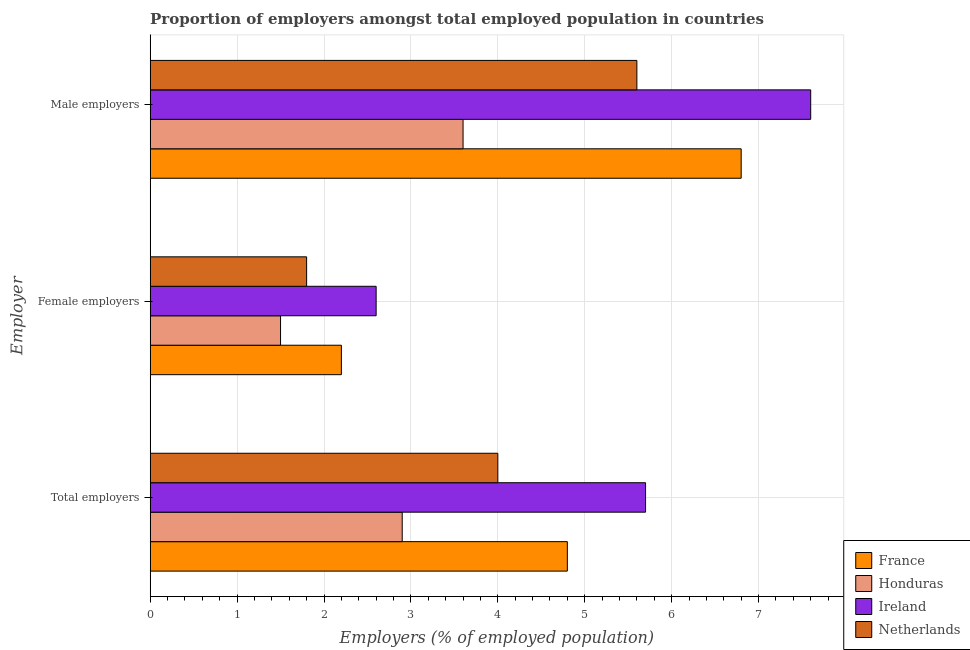How many groups of bars are there?
Offer a very short reply. 3. Are the number of bars per tick equal to the number of legend labels?
Ensure brevity in your answer.  Yes. Are the number of bars on each tick of the Y-axis equal?
Offer a very short reply. Yes. How many bars are there on the 2nd tick from the top?
Your response must be concise. 4. How many bars are there on the 2nd tick from the bottom?
Ensure brevity in your answer.  4. What is the label of the 2nd group of bars from the top?
Give a very brief answer. Female employers. What is the percentage of total employers in Netherlands?
Offer a terse response. 4. Across all countries, what is the maximum percentage of male employers?
Your answer should be very brief. 7.6. Across all countries, what is the minimum percentage of male employers?
Offer a terse response. 3.6. In which country was the percentage of male employers maximum?
Give a very brief answer. Ireland. In which country was the percentage of male employers minimum?
Offer a very short reply. Honduras. What is the total percentage of total employers in the graph?
Your answer should be compact. 17.4. What is the difference between the percentage of female employers in Ireland and that in France?
Your response must be concise. 0.4. What is the difference between the percentage of male employers in France and the percentage of total employers in Honduras?
Make the answer very short. 3.9. What is the average percentage of female employers per country?
Ensure brevity in your answer.  2.02. What is the difference between the percentage of female employers and percentage of male employers in Netherlands?
Offer a very short reply. -3.8. What is the ratio of the percentage of male employers in France to that in Netherlands?
Offer a terse response. 1.21. What is the difference between the highest and the second highest percentage of female employers?
Your response must be concise. 0.4. What is the difference between the highest and the lowest percentage of total employers?
Your answer should be compact. 2.8. Is the sum of the percentage of male employers in Honduras and Netherlands greater than the maximum percentage of female employers across all countries?
Keep it short and to the point. Yes. What does the 3rd bar from the top in Female employers represents?
Provide a succinct answer. Honduras. What does the 1st bar from the bottom in Total employers represents?
Give a very brief answer. France. Is it the case that in every country, the sum of the percentage of total employers and percentage of female employers is greater than the percentage of male employers?
Make the answer very short. Yes. How many bars are there?
Ensure brevity in your answer.  12. How many countries are there in the graph?
Your answer should be compact. 4. Does the graph contain any zero values?
Your answer should be compact. No. Does the graph contain grids?
Provide a short and direct response. Yes. How many legend labels are there?
Keep it short and to the point. 4. What is the title of the graph?
Your answer should be compact. Proportion of employers amongst total employed population in countries. Does "High income" appear as one of the legend labels in the graph?
Ensure brevity in your answer.  No. What is the label or title of the X-axis?
Offer a very short reply. Employers (% of employed population). What is the label or title of the Y-axis?
Make the answer very short. Employer. What is the Employers (% of employed population) of France in Total employers?
Keep it short and to the point. 4.8. What is the Employers (% of employed population) in Honduras in Total employers?
Provide a succinct answer. 2.9. What is the Employers (% of employed population) of Ireland in Total employers?
Make the answer very short. 5.7. What is the Employers (% of employed population) of Netherlands in Total employers?
Your answer should be compact. 4. What is the Employers (% of employed population) of France in Female employers?
Provide a succinct answer. 2.2. What is the Employers (% of employed population) of Ireland in Female employers?
Give a very brief answer. 2.6. What is the Employers (% of employed population) in Netherlands in Female employers?
Your response must be concise. 1.8. What is the Employers (% of employed population) of France in Male employers?
Keep it short and to the point. 6.8. What is the Employers (% of employed population) of Honduras in Male employers?
Keep it short and to the point. 3.6. What is the Employers (% of employed population) in Ireland in Male employers?
Your answer should be very brief. 7.6. What is the Employers (% of employed population) of Netherlands in Male employers?
Provide a succinct answer. 5.6. Across all Employer, what is the maximum Employers (% of employed population) in France?
Your response must be concise. 6.8. Across all Employer, what is the maximum Employers (% of employed population) in Honduras?
Provide a short and direct response. 3.6. Across all Employer, what is the maximum Employers (% of employed population) of Ireland?
Your answer should be compact. 7.6. Across all Employer, what is the maximum Employers (% of employed population) of Netherlands?
Offer a terse response. 5.6. Across all Employer, what is the minimum Employers (% of employed population) in France?
Keep it short and to the point. 2.2. Across all Employer, what is the minimum Employers (% of employed population) of Honduras?
Keep it short and to the point. 1.5. Across all Employer, what is the minimum Employers (% of employed population) in Ireland?
Your answer should be very brief. 2.6. Across all Employer, what is the minimum Employers (% of employed population) in Netherlands?
Make the answer very short. 1.8. What is the total Employers (% of employed population) in France in the graph?
Keep it short and to the point. 13.8. What is the total Employers (% of employed population) in Ireland in the graph?
Your answer should be compact. 15.9. What is the total Employers (% of employed population) in Netherlands in the graph?
Ensure brevity in your answer.  11.4. What is the difference between the Employers (% of employed population) in France in Total employers and that in Female employers?
Offer a terse response. 2.6. What is the difference between the Employers (% of employed population) of Honduras in Total employers and that in Female employers?
Offer a very short reply. 1.4. What is the difference between the Employers (% of employed population) in Ireland in Total employers and that in Female employers?
Provide a succinct answer. 3.1. What is the difference between the Employers (% of employed population) in France in Total employers and that in Male employers?
Your response must be concise. -2. What is the difference between the Employers (% of employed population) in Honduras in Total employers and that in Male employers?
Ensure brevity in your answer.  -0.7. What is the difference between the Employers (% of employed population) of France in Female employers and that in Male employers?
Your answer should be very brief. -4.6. What is the difference between the Employers (% of employed population) of Honduras in Female employers and that in Male employers?
Give a very brief answer. -2.1. What is the difference between the Employers (% of employed population) of Netherlands in Female employers and that in Male employers?
Provide a short and direct response. -3.8. What is the difference between the Employers (% of employed population) of France in Total employers and the Employers (% of employed population) of Honduras in Female employers?
Ensure brevity in your answer.  3.3. What is the difference between the Employers (% of employed population) of Honduras in Total employers and the Employers (% of employed population) of Ireland in Female employers?
Give a very brief answer. 0.3. What is the difference between the Employers (% of employed population) in France in Total employers and the Employers (% of employed population) in Netherlands in Male employers?
Give a very brief answer. -0.8. What is the difference between the Employers (% of employed population) of France in Female employers and the Employers (% of employed population) of Honduras in Male employers?
Your response must be concise. -1.4. What is the difference between the Employers (% of employed population) of France in Female employers and the Employers (% of employed population) of Ireland in Male employers?
Make the answer very short. -5.4. What is the difference between the Employers (% of employed population) in France in Female employers and the Employers (% of employed population) in Netherlands in Male employers?
Offer a terse response. -3.4. What is the difference between the Employers (% of employed population) of Honduras in Female employers and the Employers (% of employed population) of Ireland in Male employers?
Ensure brevity in your answer.  -6.1. What is the average Employers (% of employed population) in Honduras per Employer?
Give a very brief answer. 2.67. What is the average Employers (% of employed population) in Ireland per Employer?
Provide a short and direct response. 5.3. What is the difference between the Employers (% of employed population) in France and Employers (% of employed population) in Ireland in Total employers?
Your response must be concise. -0.9. What is the difference between the Employers (% of employed population) of Honduras and Employers (% of employed population) of Ireland in Total employers?
Offer a terse response. -2.8. What is the difference between the Employers (% of employed population) in Honduras and Employers (% of employed population) in Netherlands in Total employers?
Offer a terse response. -1.1. What is the difference between the Employers (% of employed population) of France and Employers (% of employed population) of Ireland in Female employers?
Ensure brevity in your answer.  -0.4. What is the difference between the Employers (% of employed population) of Honduras and Employers (% of employed population) of Ireland in Female employers?
Your response must be concise. -1.1. What is the difference between the Employers (% of employed population) of France and Employers (% of employed population) of Netherlands in Male employers?
Provide a short and direct response. 1.2. What is the difference between the Employers (% of employed population) in Ireland and Employers (% of employed population) in Netherlands in Male employers?
Give a very brief answer. 2. What is the ratio of the Employers (% of employed population) in France in Total employers to that in Female employers?
Make the answer very short. 2.18. What is the ratio of the Employers (% of employed population) in Honduras in Total employers to that in Female employers?
Give a very brief answer. 1.93. What is the ratio of the Employers (% of employed population) of Ireland in Total employers to that in Female employers?
Your response must be concise. 2.19. What is the ratio of the Employers (% of employed population) of Netherlands in Total employers to that in Female employers?
Offer a terse response. 2.22. What is the ratio of the Employers (% of employed population) in France in Total employers to that in Male employers?
Give a very brief answer. 0.71. What is the ratio of the Employers (% of employed population) in Honduras in Total employers to that in Male employers?
Provide a short and direct response. 0.81. What is the ratio of the Employers (% of employed population) in Netherlands in Total employers to that in Male employers?
Your answer should be compact. 0.71. What is the ratio of the Employers (% of employed population) of France in Female employers to that in Male employers?
Your answer should be very brief. 0.32. What is the ratio of the Employers (% of employed population) in Honduras in Female employers to that in Male employers?
Your answer should be very brief. 0.42. What is the ratio of the Employers (% of employed population) in Ireland in Female employers to that in Male employers?
Provide a succinct answer. 0.34. What is the ratio of the Employers (% of employed population) of Netherlands in Female employers to that in Male employers?
Make the answer very short. 0.32. What is the difference between the highest and the second highest Employers (% of employed population) of France?
Your answer should be compact. 2. What is the difference between the highest and the second highest Employers (% of employed population) of Ireland?
Offer a terse response. 1.9. What is the difference between the highest and the second highest Employers (% of employed population) in Netherlands?
Your response must be concise. 1.6. What is the difference between the highest and the lowest Employers (% of employed population) of France?
Keep it short and to the point. 4.6. What is the difference between the highest and the lowest Employers (% of employed population) of Ireland?
Provide a short and direct response. 5. What is the difference between the highest and the lowest Employers (% of employed population) of Netherlands?
Your answer should be very brief. 3.8. 